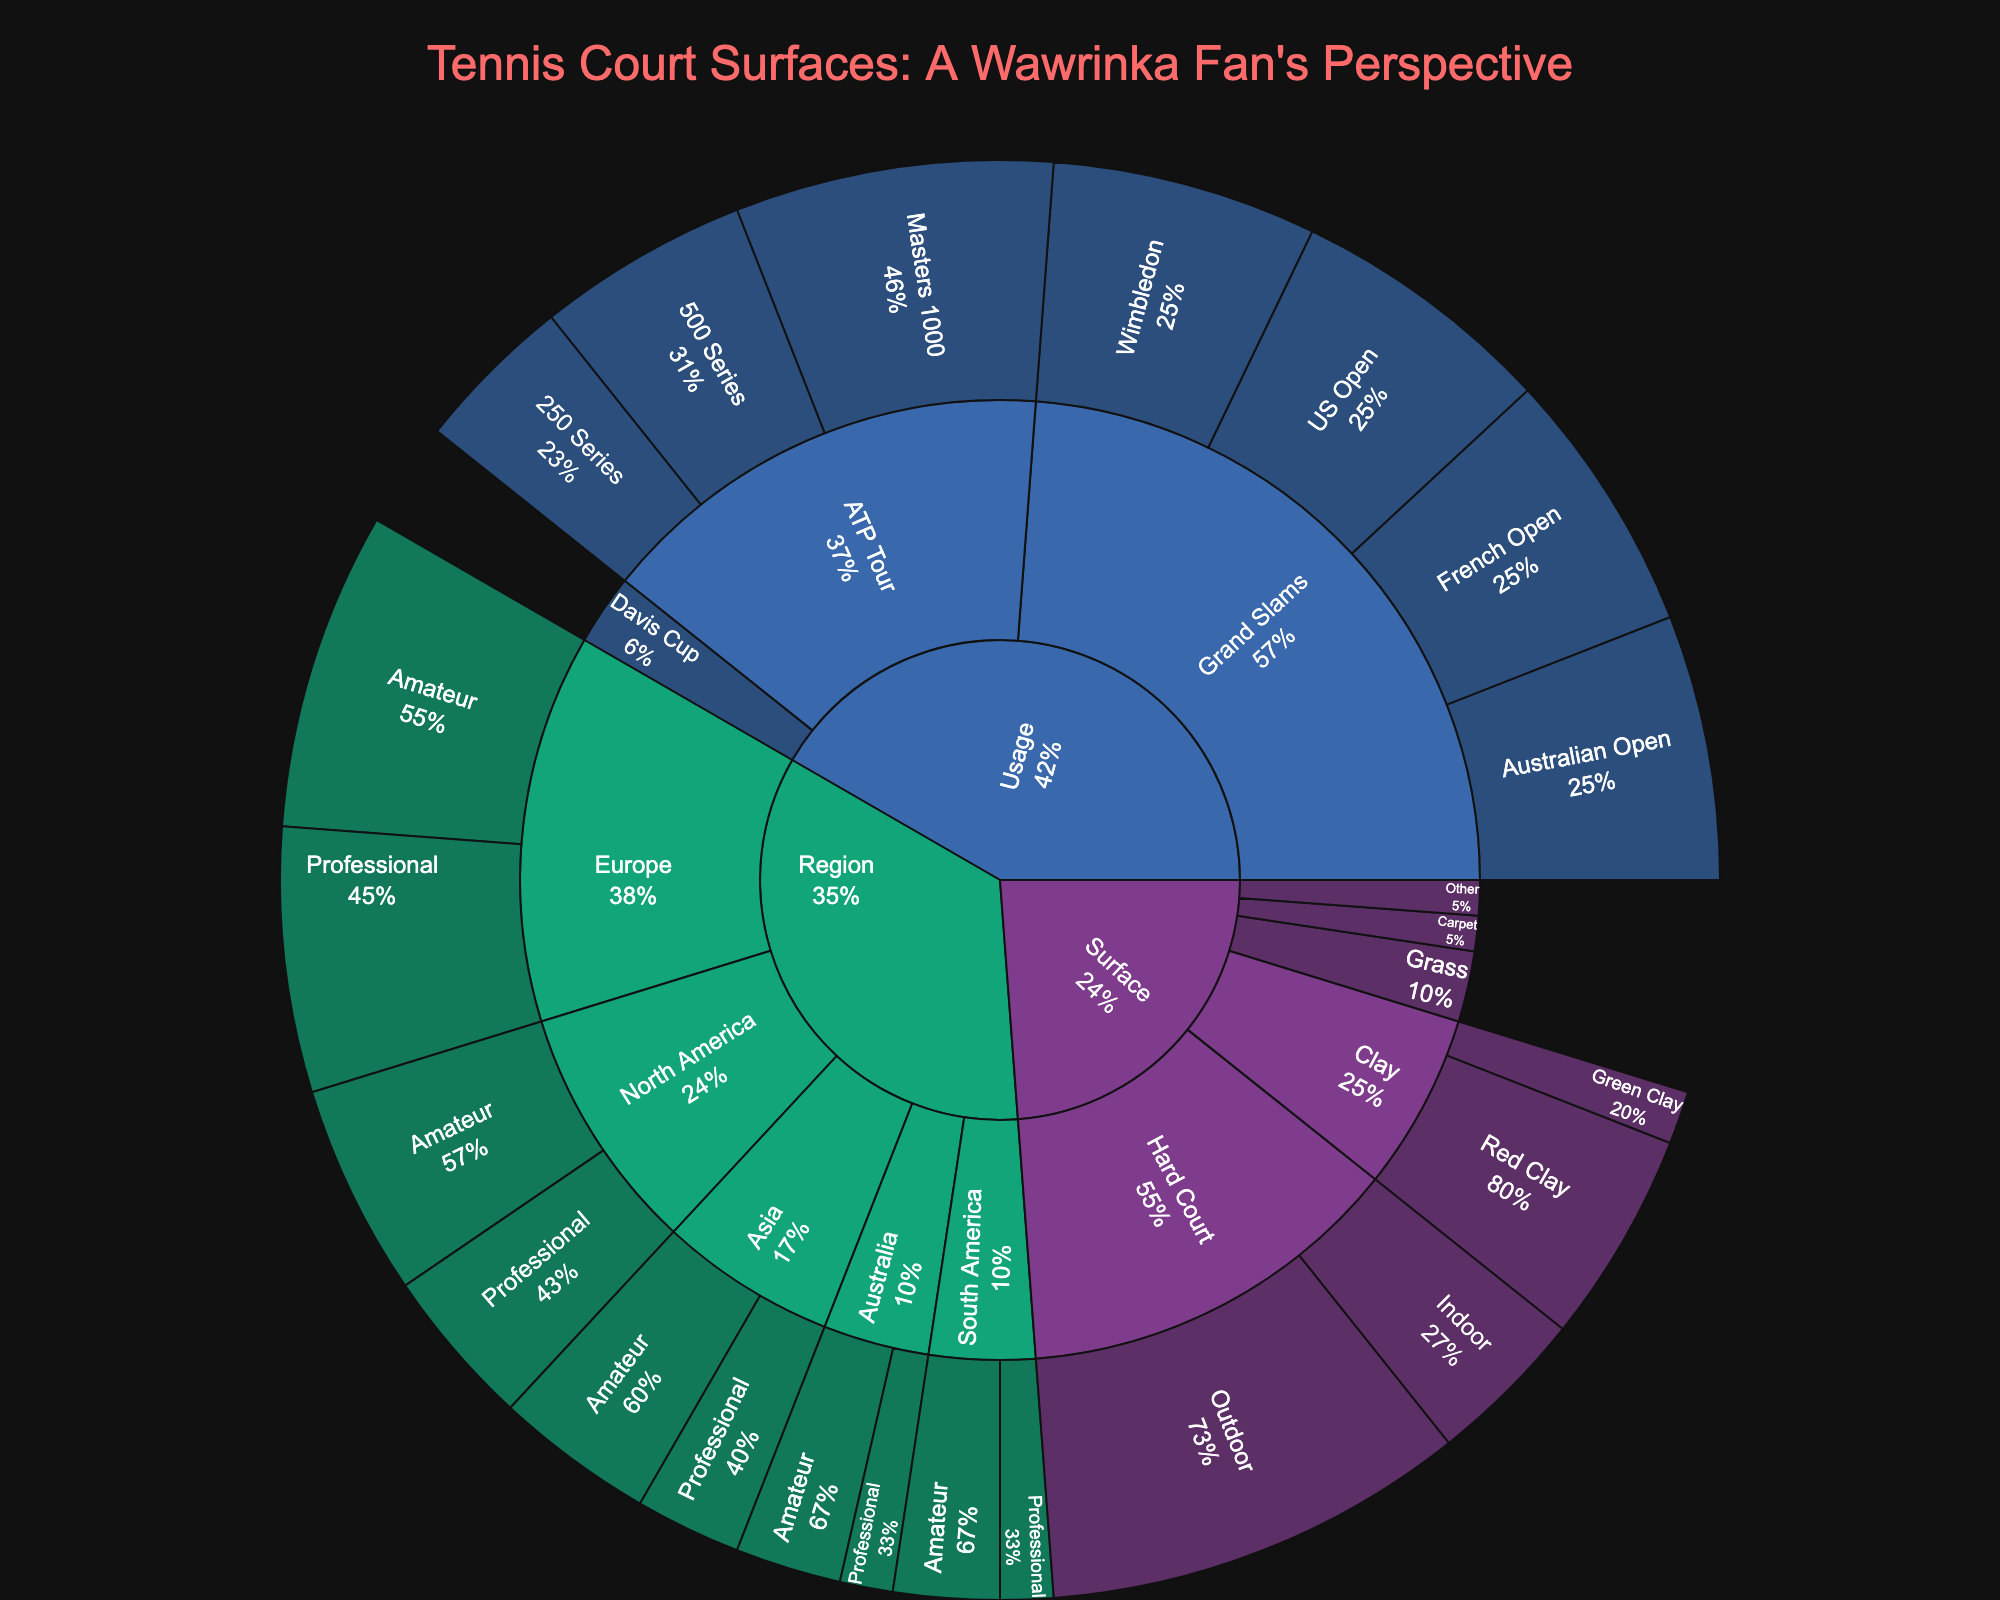What is the title of the Sunburst plot? The title of the plot is prominently displayed at the top and usually describes the subject of the visualization.
Answer: Tennis Court Surfaces: A Wawrinka Fan's Perspective Which surface type has the highest value in terms of outdoor courts? By examining the Sunburst plot sections, we can see which surface type has the biggest proportion in the 'Outdoor' subcategory.
Answer: Hard Court What is the combined value for Europe under the 'Professional' and 'Amateur' categories? Examine the segments under the 'Europe' category and sum the values for 'Professional' and 'Amateur' subcategories. Professional = 25, Amateur = 30; 25 + 30 = 55
Answer: 55 Which region has the most evenly split values between professional and amateur usage? Compare the professional and amateur values for each region to determine which one has the closest values.
Answer: South America (both are 5 and 10) What is the percentage share of Indoor Hard Courts compared to all Hard Courts? First, sum all the values under 'Hard Court' which is 40 (Outdoor) + 15 (Indoor) = 55. Then, calculate the percentage of Indoor Hard Court value which is (15/55)*100%.
Answer: 27.27% Which Grand Slam event has the same value in the plot? Identify the Grand Slam events on the plot and check which have identical values. Australian Open, French Open, Wimbledon, and US Open sections all have the same value.
Answer: Australian Open, French Open, Wimbledon, US Open How does the value of Masters 1000 compare to the combined value of 500 Series and 250 Series in ATP Tour? Look at the segments under 'ATP Tour'. Masters 1000 = 30, 500 Series = 20, 250 Series = 15. Sum 500 Series and 250 Series (20 + 15 = 35) and compare it to Masters 1000.
Answer: Less What surface type has the smallest value, and what is that value? Look at the Sunburst plot and identify the smallest section value under the 'Surface' category.
Answer: Carpet, 5 Which region has the least representation in the Sunburst plot and what are the values? Check all the regions and find the one with the smallest cumulative value in both 'Professional' and 'Amateur' categories.
Answer: Australia, Professional: 5, Amateur: 10 Compare the total values of all categories under 'Usage' to 'Region'. Which one is larger and by how much? Sum the values under 'Usage' and 'Region'. Usage total = 25+25+25+25+30+20+15+10 = 175. Region total = 25+30+15+20+10+15+5+10+5+10 = 145. Compare the totals. 175 - 145 = 30
Answer: Usage, by 30 